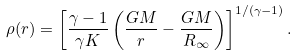<formula> <loc_0><loc_0><loc_500><loc_500>\rho ( r ) = \left [ \frac { \gamma - 1 } { \gamma K } \left ( \frac { G M } { r } - \frac { G M } { R _ { \infty } } \right ) \right ] ^ { 1 / ( \gamma - 1 ) } .</formula> 